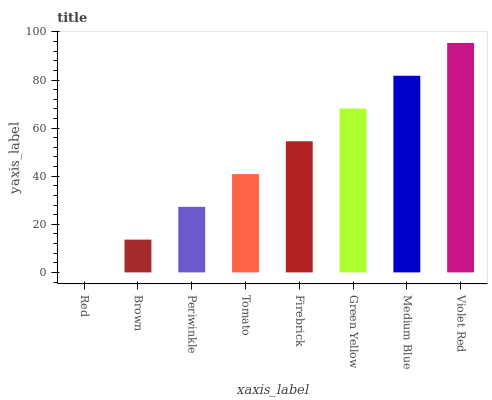Is Red the minimum?
Answer yes or no. Yes. Is Violet Red the maximum?
Answer yes or no. Yes. Is Brown the minimum?
Answer yes or no. No. Is Brown the maximum?
Answer yes or no. No. Is Brown greater than Red?
Answer yes or no. Yes. Is Red less than Brown?
Answer yes or no. Yes. Is Red greater than Brown?
Answer yes or no. No. Is Brown less than Red?
Answer yes or no. No. Is Firebrick the high median?
Answer yes or no. Yes. Is Tomato the low median?
Answer yes or no. Yes. Is Green Yellow the high median?
Answer yes or no. No. Is Red the low median?
Answer yes or no. No. 